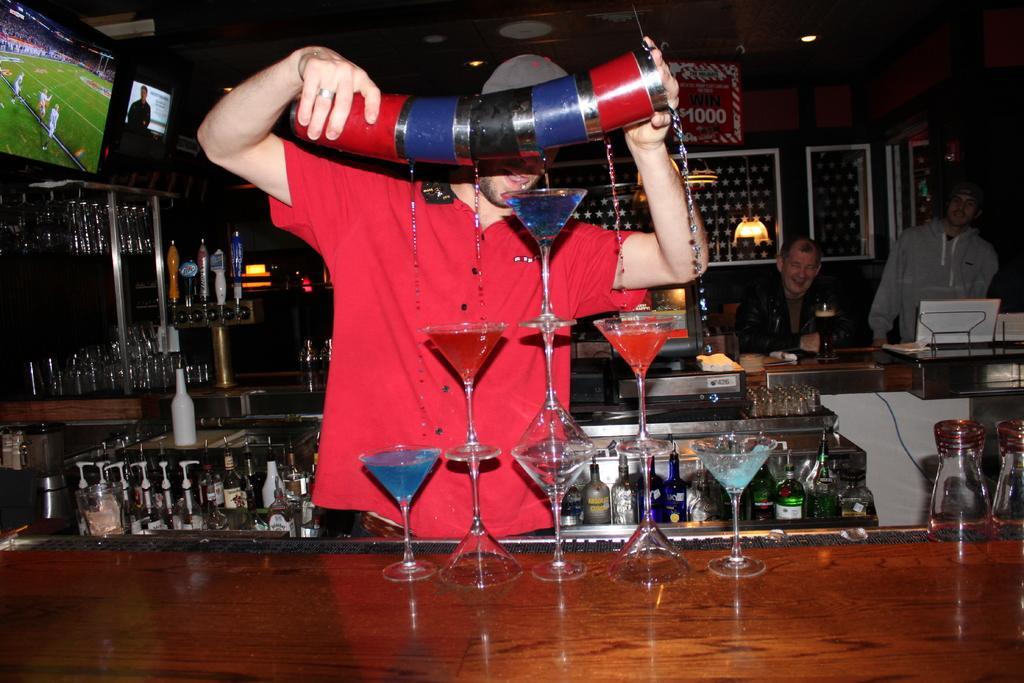In one or two sentences, can you explain what this image depicts? This image consists of a man wearing red shirt. He is pouring cocktails in the glasses. It looks like a bar counter. To the left, top, there is a TV. In the background, there are many bottle and two persons sitting. At the bottom, there is a table. 